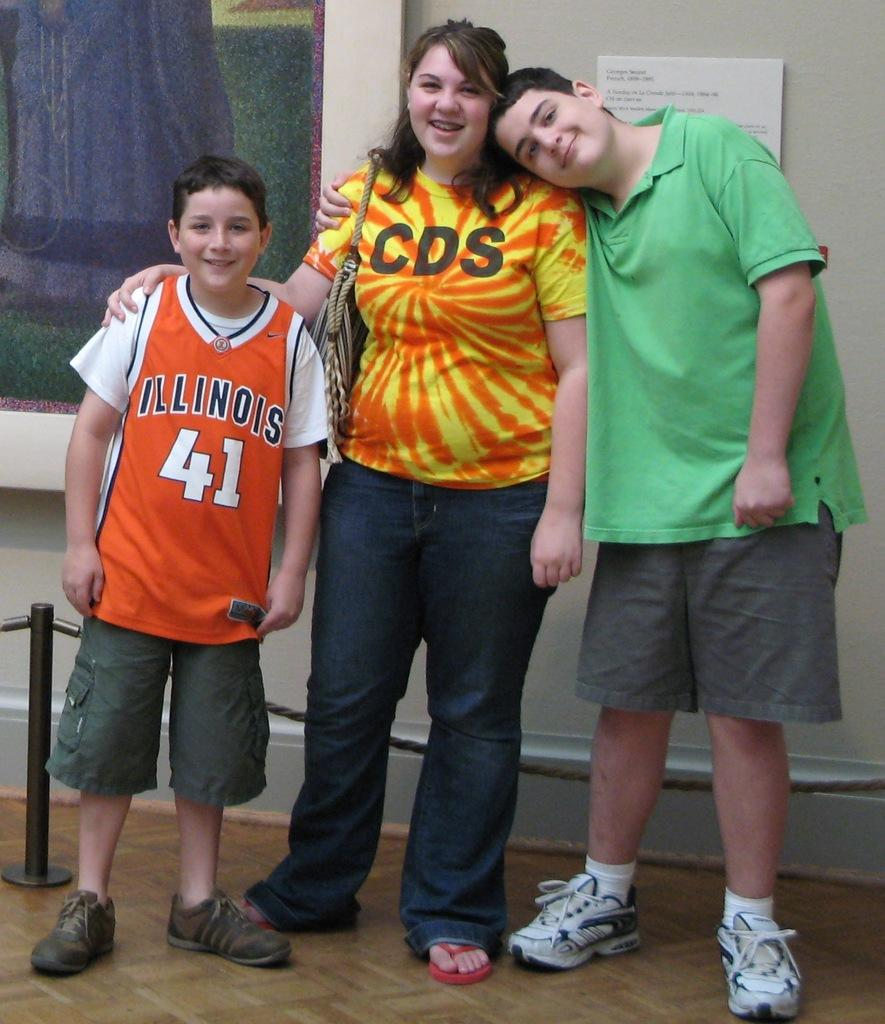<image>
Relay a brief, clear account of the picture shown. a boy standing with a family and the word Illinois on the jersey 